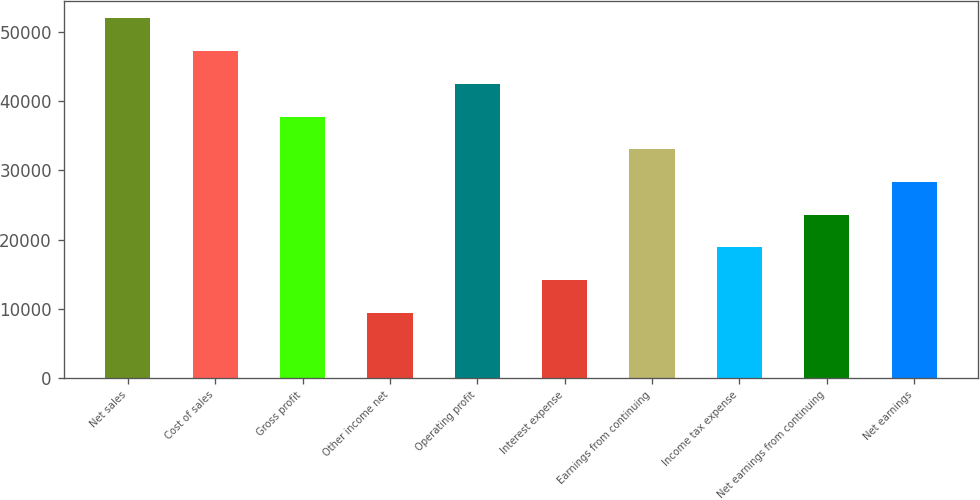<chart> <loc_0><loc_0><loc_500><loc_500><bar_chart><fcel>Net sales<fcel>Cost of sales<fcel>Gross profit<fcel>Other income net<fcel>Operating profit<fcel>Interest expense<fcel>Earnings from continuing<fcel>Income tax expense<fcel>Net earnings from continuing<fcel>Net earnings<nl><fcel>51899.3<fcel>47182<fcel>37747.2<fcel>9443.08<fcel>42464.6<fcel>14160.4<fcel>33029.9<fcel>18877.8<fcel>23595.2<fcel>28312.5<nl></chart> 